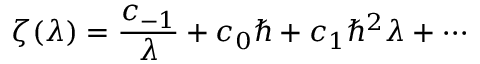<formula> <loc_0><loc_0><loc_500><loc_500>\zeta ( \lambda ) = \frac { c _ { - 1 } } { \lambda } + c _ { 0 } \hbar { + } c _ { 1 } \hbar { ^ } { 2 } \lambda + \cdots</formula> 